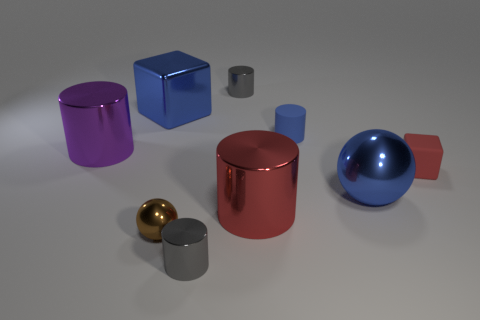Subtract 1 cylinders. How many cylinders are left? 4 Subtract all purple shiny cylinders. How many cylinders are left? 4 Subtract all blue cylinders. How many cylinders are left? 4 Subtract all green cylinders. Subtract all purple balls. How many cylinders are left? 5 Add 1 metal things. How many objects exist? 10 Subtract all cubes. How many objects are left? 7 Subtract all tiny cyan blocks. Subtract all tiny spheres. How many objects are left? 8 Add 7 large metal spheres. How many large metal spheres are left? 8 Add 3 small red objects. How many small red objects exist? 4 Subtract 1 blue spheres. How many objects are left? 8 